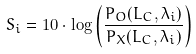Convert formula to latex. <formula><loc_0><loc_0><loc_500><loc_500>S _ { i } = 1 0 \cdot \log \left ( \frac { P _ { O } ( L _ { C } , \lambda _ { i } ) } { P _ { X } ( L _ { C } , \lambda _ { i } ) } \right )</formula> 